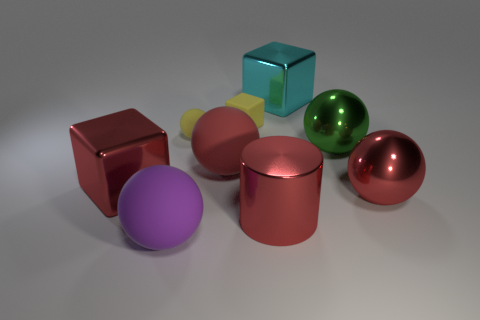What is the big red thing that is right of the tiny yellow rubber cube and left of the cyan cube made of?
Your answer should be compact. Metal. What number of purple spheres are in front of the cyan cube?
Provide a succinct answer. 1. There is a big red matte thing; is it the same shape as the red shiny object that is to the right of the large cyan metallic cube?
Offer a terse response. Yes. Is there a yellow matte object that has the same shape as the purple thing?
Offer a terse response. Yes. There is a big metal object that is behind the green metallic ball in front of the tiny yellow matte block; what is its shape?
Ensure brevity in your answer.  Cube. What shape is the shiny object that is behind the small yellow sphere?
Give a very brief answer. Cube. There is a small matte thing that is right of the large red rubber thing; is it the same color as the matte sphere that is behind the green metallic ball?
Give a very brief answer. Yes. What number of red balls are both left of the big green shiny sphere and in front of the red rubber sphere?
Your answer should be compact. 0. What is the size of the red object that is the same material as the tiny yellow block?
Your answer should be very brief. Large. The purple object is what size?
Provide a short and direct response. Large. 